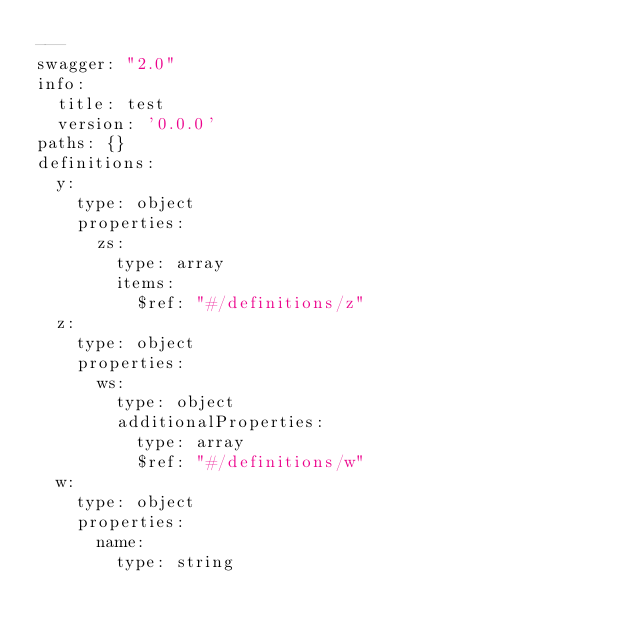Convert code to text. <code><loc_0><loc_0><loc_500><loc_500><_YAML_>---
swagger: "2.0"
info:
  title: test
  version: '0.0.0'
paths: {}
definitions:
  y:
    type: object
    properties:
      zs:
        type: array
        items:
          $ref: "#/definitions/z"
  z:
    type: object
    properties:
      ws:
        type: object
        additionalProperties:
          type: array
          $ref: "#/definitions/w"
  w:
    type: object
    properties:
      name:
        type: string
</code> 